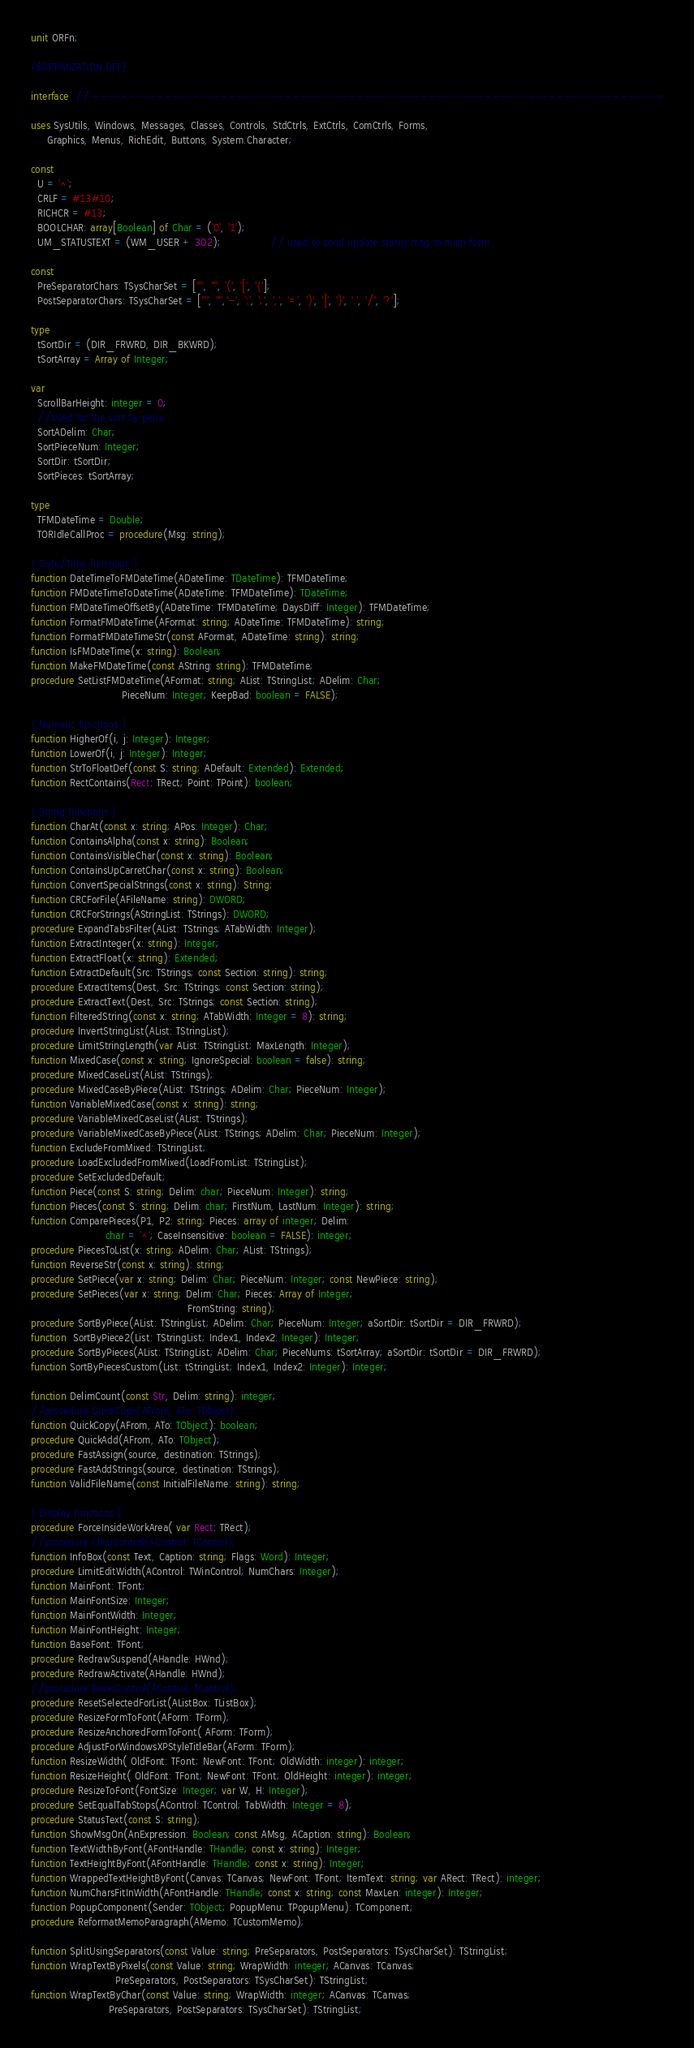<code> <loc_0><loc_0><loc_500><loc_500><_Pascal_>unit ORFn;

{$OPTIMIZATION OFF}

interface  // --------------------------------------------------------------------------------

uses SysUtils, Windows, Messages, Classes, Controls, StdCtrls, ExtCtrls, ComCtrls, Forms,
     Graphics, Menus, RichEdit, Buttons, System.Character;

const
  U = '^';
  CRLF = #13#10;
  RICHCR = #13;
  BOOLCHAR: array[Boolean] of Char = ('0', '1');
  UM_STATUSTEXT = (WM_USER + 302);               // used to send update status msg to main form

const
  PreSeparatorChars: TSysCharSet = ['''', '"', '(', '[', '{'];
  PostSeparatorChars: TSysCharSet = ['''', '"','-', ':', ';', ',', '=', ')', ']', '}', '.', '/', '?'];

type
  tSortDir = (DIR_FRWRD, DIR_BKWRD);
  tSortArray = Array of Integer;

var
  ScrollBarHeight: integer = 0;
  //Used for the sort by peice
  SortADelim: Char;
  SortPieceNum: Integer;
  SortDir: tSortDir;
  SortPieces: tSortArray;

type
  TFMDateTime = Double;
  TORIdleCallProc = procedure(Msg: string);

{ Date/Time functions }
function DateTimeToFMDateTime(ADateTime: TDateTime): TFMDateTime;
function FMDateTimeToDateTime(ADateTime: TFMDateTime): TDateTime;
function FMDateTimeOffsetBy(ADateTime: TFMDateTime; DaysDiff: Integer): TFMDateTime;
function FormatFMDateTime(AFormat: string; ADateTime: TFMDateTime): string;
function FormatFMDateTimeStr(const AFormat, ADateTime: string): string;
function IsFMDateTime(x: string): Boolean;
function MakeFMDateTime(const AString: string): TFMDateTime;
procedure SetListFMDateTime(AFormat: string; AList: TStringList; ADelim: Char;
                            PieceNum: Integer; KeepBad: boolean = FALSE);

{ Numeric functions }
function HigherOf(i, j: Integer): Integer;
function LowerOf(i, j: Integer): Integer;
function StrToFloatDef(const S: string; ADefault: Extended): Extended;
function RectContains(Rect: TRect; Point: TPoint): boolean;

{ String functions }
function CharAt(const x: string; APos: Integer): Char;
function ContainsAlpha(const x: string): Boolean;
function ContainsVisibleChar(const x: string): Boolean;
function ContainsUpCarretChar(const x: string): Boolean;
function ConvertSpecialStrings(const x: string): String;
function CRCForFile(AFileName: string): DWORD;
function CRCForStrings(AStringList: TStrings): DWORD;
procedure ExpandTabsFilter(AList: TStrings; ATabWidth: Integer);
function ExtractInteger(x: string): Integer;
function ExtractFloat(x: string): Extended;
function ExtractDefault(Src: TStrings; const Section: string): string;
procedure ExtractItems(Dest, Src: TStrings; const Section: string);
procedure ExtractText(Dest, Src: TStrings; const Section: string);
function FilteredString(const x: string; ATabWidth: Integer = 8): string;
procedure InvertStringList(AList: TStringList);
procedure LimitStringLength(var AList: TStringList; MaxLength: Integer);
function MixedCase(const x: string; IgnoreSpecial: boolean = false): string;
procedure MixedCaseList(AList: TStrings);
procedure MixedCaseByPiece(AList: TStrings; ADelim: Char; PieceNum: Integer);
function VariableMixedCase(const x: string): string;
procedure VariableMixedCaseList(AList: TStrings);
procedure VariableMixedCaseByPiece(AList: TStrings; ADelim: Char; PieceNum: Integer);
function ExcludeFromMixed: TStringList;
procedure LoadExcludedFromMixed(LoadFromList: TStringList);
procedure SetExcludedDefault;
function Piece(const S: string; Delim: char; PieceNum: Integer): string;
function Pieces(const S: string; Delim: char; FirstNum, LastNum: Integer): string;
function ComparePieces(P1, P2: string; Pieces: array of integer; Delim:
                       char = '^'; CaseInsensitive: boolean = FALSE): integer;
procedure PiecesToList(x: string; ADelim: Char; AList: TStrings);
function ReverseStr(const x: string): string;
procedure SetPiece(var x: string; Delim: Char; PieceNum: Integer; const NewPiece: string);
procedure SetPieces(var x: string; Delim: Char; Pieces: Array of Integer;
                                                FromString: string);
procedure SortByPiece(AList: TStringList; ADelim: Char; PieceNum: Integer; aSortDir: tSortDir = DIR_FRWRD);
function  SortByPiece2(List: TStringList; Index1, Index2: Integer): Integer;
procedure SortByPieces(AList: TStringList; ADelim: Char; PieceNums: tSortArray; aSortDir: tSortDir = DIR_FRWRD);
function SortByPiecesCustom(List: tStringList; Index1, Index2: Integer): Integer;

function DelimCount(const Str, Delim: string): integer;
//procedure QuickCopy(AFrom, ATo: TObject);
function QuickCopy(AFrom, ATo: TObject): boolean;
procedure QuickAdd(AFrom, ATo: TObject);
procedure FastAssign(source, destination: TStrings);
procedure FastAddStrings(source, destination: TStrings);
function ValidFileName(const InitialFileName: string): string;

{ Display functions }
procedure ForceInsideWorkArea( var Rect: TRect);
//procedure ClearControl(AControl: TControl);
function InfoBox(const Text, Caption: string; Flags: Word): Integer;
procedure LimitEditWidth(AControl: TWinControl; NumChars: Integer);
function MainFont: TFont;
function MainFontSize: Integer;
function MainFontWidth: Integer;
function MainFontHeight: Integer;
function BaseFont: TFont;
procedure RedrawSuspend(AHandle: HWnd);
procedure RedrawActivate(AHandle: HWnd);
//procedure ResetControl(AControl: TControl);
procedure ResetSelectedForList(AListBox: TListBox);
procedure ResizeFormToFont(AForm: TForm);
procedure ResizeAnchoredFormToFont( AForm: TForm);
procedure AdjustForWindowsXPStyleTitleBar(AForm: TForm);
function ResizeWidth( OldFont: TFont; NewFont: TFont; OldWidth: integer): integer;
function ResizeHeight( OldFont: TFont; NewFont: TFont; OldHeight: integer): integer;
procedure ResizeToFont(FontSize: Integer; var W, H: Integer);
procedure SetEqualTabStops(AControl: TControl; TabWidth: Integer = 8);
procedure StatusText(const S: string);
function ShowMsgOn(AnExpression: Boolean; const AMsg, ACaption: string): Boolean;
function TextWidthByFont(AFontHandle: THandle; const x: string): Integer;
function TextHeightByFont(AFontHandle: THandle; const x: string): Integer;
function WrappedTextHeightByFont(Canvas: TCanvas; NewFont: TFont; ItemText: string; var ARect: TRect): integer;
function NumCharsFitInWidth(AFontHandle: THandle; const x: string; const MaxLen: integer): Integer;
function PopupComponent(Sender: TObject; PopupMenu: TPopupMenu): TComponent;
procedure ReformatMemoParagraph(AMemo: TCustomMemo);

function SplitUsingSeparators(const Value: string; PreSeparators, PostSeparators: TSysCharSet): TStringList;
function WrapTextByPixels(const Value: string; WrapWidth: integer; ACanvas: TCanvas;
                          PreSeparators, PostSeparators: TSysCharSet): TStringList;
function WrapTextByChar(const Value: string; WrapWidth: integer; ACanvas: TCanvas;
                        PreSeparators, PostSeparators: TSysCharSet): TStringList;</code> 